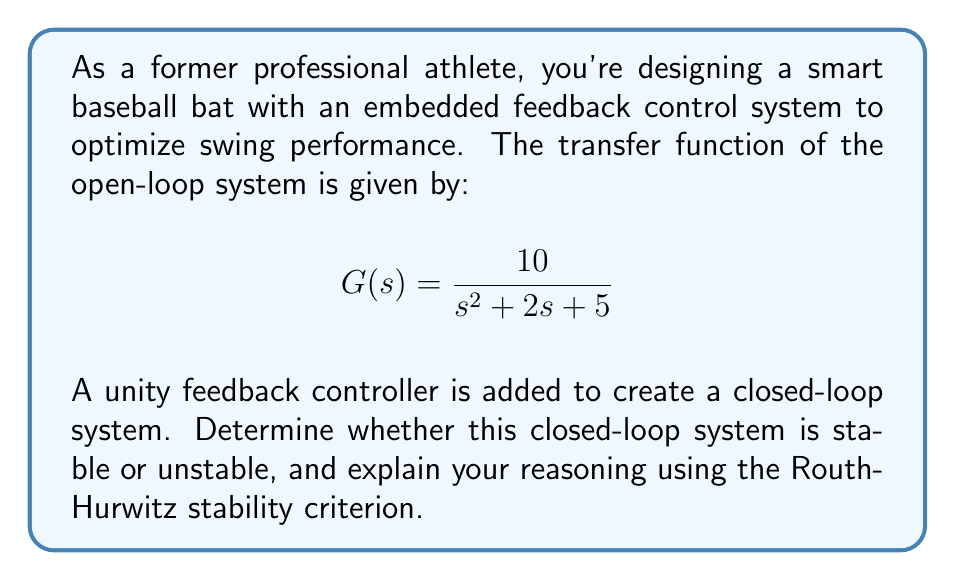Can you solve this math problem? To analyze the stability of the closed-loop system, we'll use the Routh-Hurwitz stability criterion. First, let's derive the closed-loop transfer function:

1) The closed-loop transfer function is given by:
   $$T(s) = \frac{G(s)}{1 + G(s)}$$

2) Substituting the given $G(s)$:
   $$T(s) = \frac{\frac{10}{s^2 + 2s + 5}}{1 + \frac{10}{s^2 + 2s + 5}}$$

3) Finding a common denominator:
   $$T(s) = \frac{10}{s^2 + 2s + 5 + 10} = \frac{10}{s^2 + 2s + 15}$$

4) The characteristic equation is the denominator of $T(s)$ set to zero:
   $$s^2 + 2s + 15 = 0$$

Now, let's apply the Routh-Hurwitz criterion:

5) Construct the Routh array:
   $$\begin{array}{c|cc}
   s^2 & 1 & 15 \\
   s^1 & 2 & 0 \\
   s^0 & 15 & 
   \end{array}$$

6) Check for sign changes in the first column:
   - $s^2$ row: 1 (positive)
   - $s^1$ row: 2 (positive)
   - $s^0$ row: 15 (positive)

There are no sign changes in the first column of the Routh array.

According to the Routh-Hurwitz stability criterion, a system is stable if and only if all elements in the first column of the Routh array have the same sign (all positive or all negative). In this case, all elements are positive, indicating a stable system.
Answer: The closed-loop system is stable. 